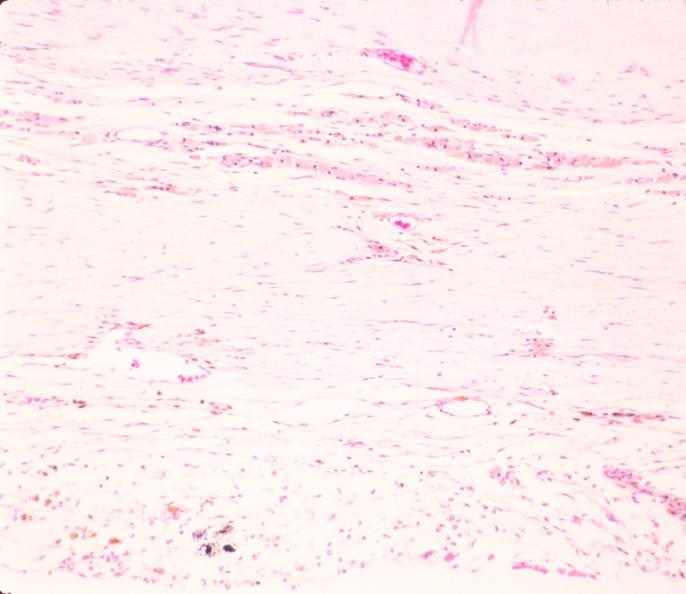what does this image show?
Answer the question using a single word or phrase. Brain 